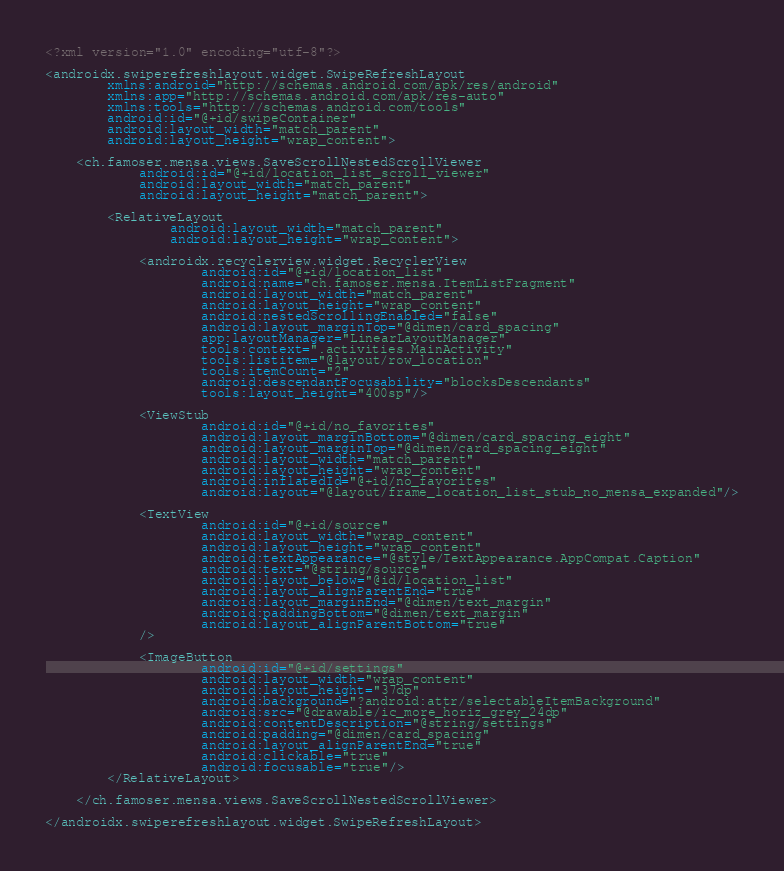<code> <loc_0><loc_0><loc_500><loc_500><_XML_><?xml version="1.0" encoding="utf-8"?>

<androidx.swiperefreshlayout.widget.SwipeRefreshLayout
        xmlns:android="http://schemas.android.com/apk/res/android"
        xmlns:app="http://schemas.android.com/apk/res-auto"
        xmlns:tools="http://schemas.android.com/tools"
        android:id="@+id/swipeContainer"
        android:layout_width="match_parent"
        android:layout_height="wrap_content">

    <ch.famoser.mensa.views.SaveScrollNestedScrollViewer
            android:id="@+id/location_list_scroll_viewer"
            android:layout_width="match_parent"
            android:layout_height="match_parent">

        <RelativeLayout
                android:layout_width="match_parent"
                android:layout_height="wrap_content">

            <androidx.recyclerview.widget.RecyclerView
                    android:id="@+id/location_list"
                    android:name="ch.famoser.mensa.ItemListFragment"
                    android:layout_width="match_parent"
                    android:layout_height="wrap_content"
                    android:nestedScrollingEnabled="false"
                    android:layout_marginTop="@dimen/card_spacing"
                    app:layoutManager="LinearLayoutManager"
                    tools:context=".activities.MainActivity"
                    tools:listitem="@layout/row_location"
                    tools:itemCount="2"
                    android:descendantFocusability="blocksDescendants"
                    tools:layout_height="400sp"/>

            <ViewStub
                    android:id="@+id/no_favorites"
                    android:layout_marginBottom="@dimen/card_spacing_eight"
                    android:layout_marginTop="@dimen/card_spacing_eight"
                    android:layout_width="match_parent"
                    android:layout_height="wrap_content"
                    android:inflatedId="@+id/no_favorites"
                    android:layout="@layout/frame_location_list_stub_no_mensa_expanded"/>

            <TextView
                    android:id="@+id/source"
                    android:layout_width="wrap_content"
                    android:layout_height="wrap_content"
                    android:textAppearance="@style/TextAppearance.AppCompat.Caption"
                    android:text="@string/source"
                    android:layout_below="@id/location_list"
                    android:layout_alignParentEnd="true"
                    android:layout_marginEnd="@dimen/text_margin"
                    android:paddingBottom="@dimen/text_margin"
                    android:layout_alignParentBottom="true"
            />

            <ImageButton
                    android:id="@+id/settings"
                    android:layout_width="wrap_content"
                    android:layout_height="37dp"
                    android:background="?android:attr/selectableItemBackground"
                    android:src="@drawable/ic_more_horiz_grey_24dp"
                    android:contentDescription="@string/settings"
                    android:padding="@dimen/card_spacing"
                    android:layout_alignParentEnd="true"
                    android:clickable="true"
                    android:focusable="true"/>
        </RelativeLayout>

    </ch.famoser.mensa.views.SaveScrollNestedScrollViewer>

</androidx.swiperefreshlayout.widget.SwipeRefreshLayout>
</code> 